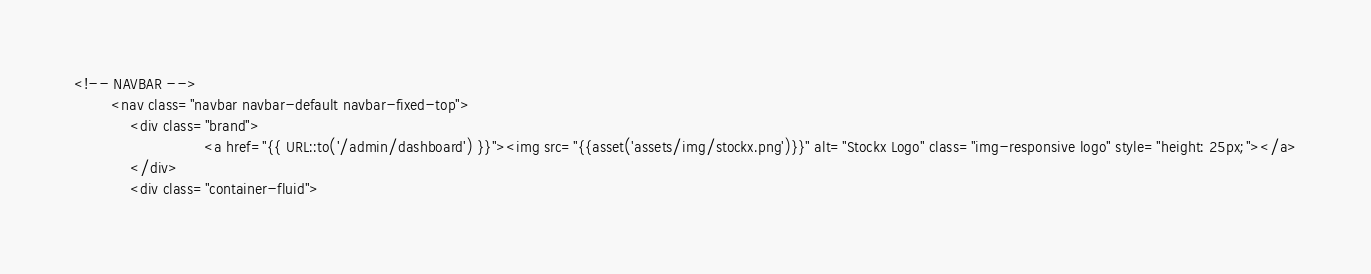Convert code to text. <code><loc_0><loc_0><loc_500><loc_500><_PHP_><!-- NAVBAR -->
		<nav class="navbar navbar-default navbar-fixed-top">
			<div class="brand">
                            <a href="{{ URL::to('/admin/dashboard') }}"><img src="{{asset('assets/img/stockx.png')}}" alt="Stockx Logo" class="img-responsive logo" style="height: 25px;"></a>
			</div>
			<div class="container-fluid">
</code> 